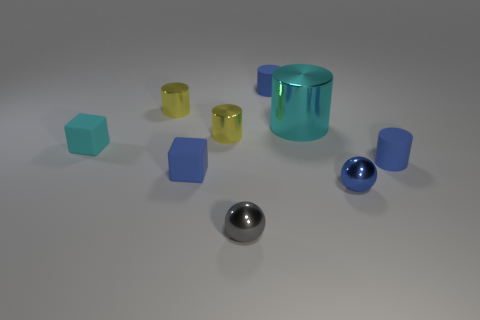Subtract all large cyan cylinders. How many cylinders are left? 4 Subtract 2 cylinders. How many cylinders are left? 3 Subtract all cyan cylinders. How many cylinders are left? 4 Subtract all gray cylinders. Subtract all yellow spheres. How many cylinders are left? 5 Add 1 large cyan objects. How many objects exist? 10 Subtract all spheres. How many objects are left? 7 Subtract 1 blue blocks. How many objects are left? 8 Subtract all tiny rubber cubes. Subtract all blue metallic objects. How many objects are left? 6 Add 6 big metal objects. How many big metal objects are left? 7 Add 1 tiny blue things. How many tiny blue things exist? 5 